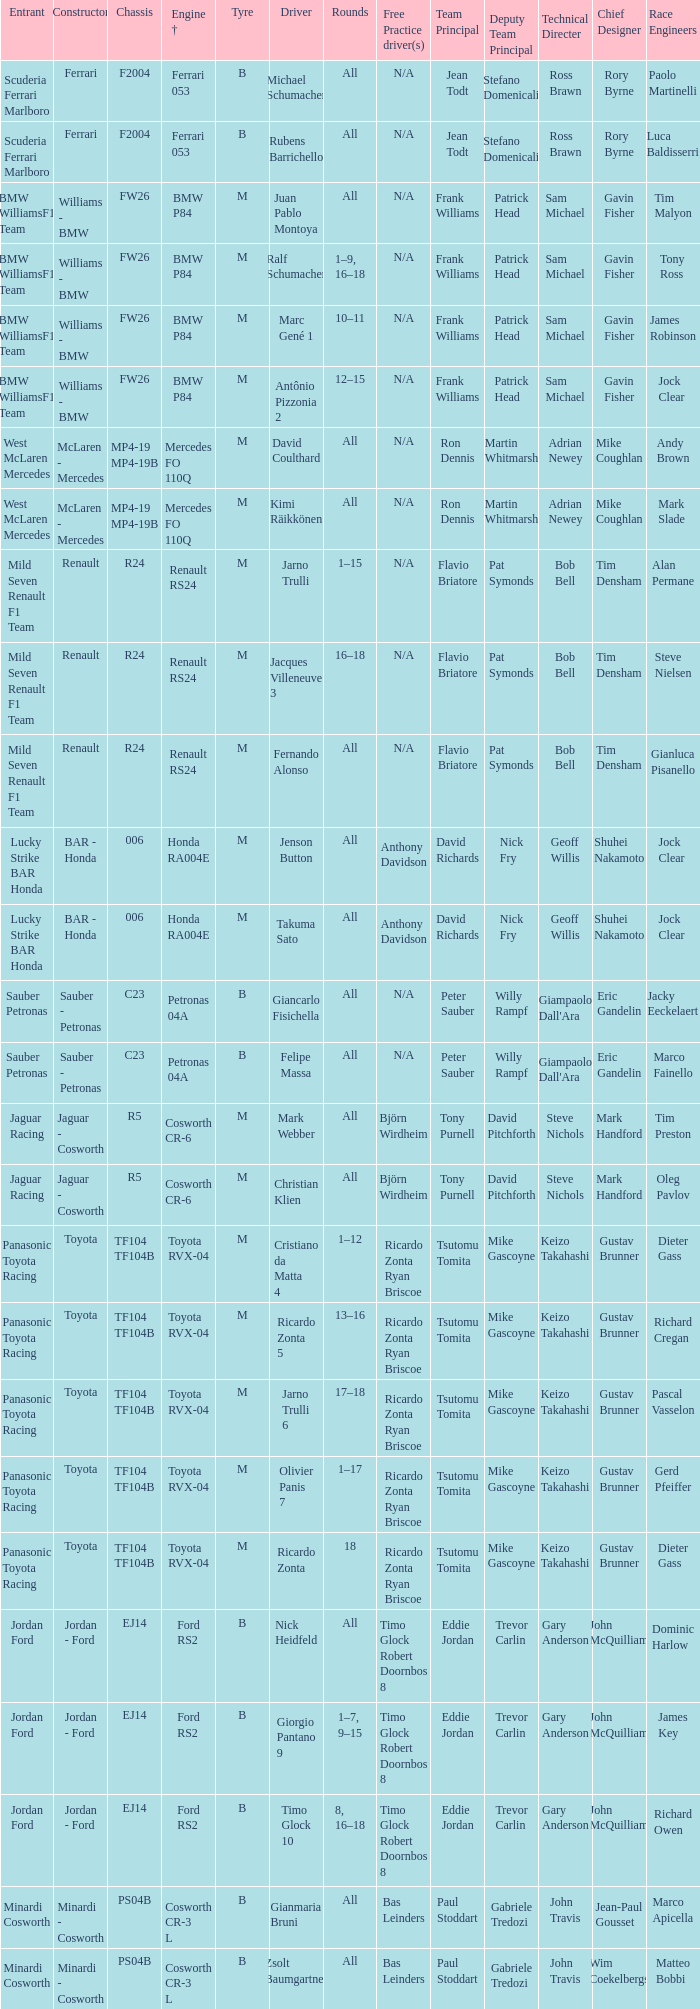What are the rounds for the B tyres and Ferrari 053 engine +? All, All. 